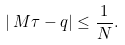Convert formula to latex. <formula><loc_0><loc_0><loc_500><loc_500>\left | { \, M \tau - q } \right | \leq \frac { 1 } { N } .</formula> 